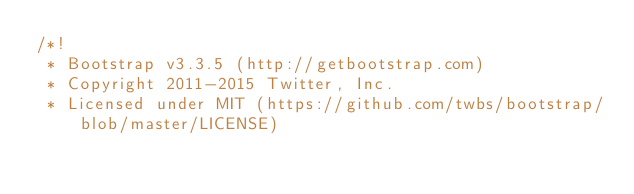Convert code to text. <code><loc_0><loc_0><loc_500><loc_500><_CSS_>/*!
 * Bootstrap v3.3.5 (http://getbootstrap.com)
 * Copyright 2011-2015 Twitter, Inc.
 * Licensed under MIT (https://github.com/twbs/bootstrap/blob/master/LICENSE)</code> 